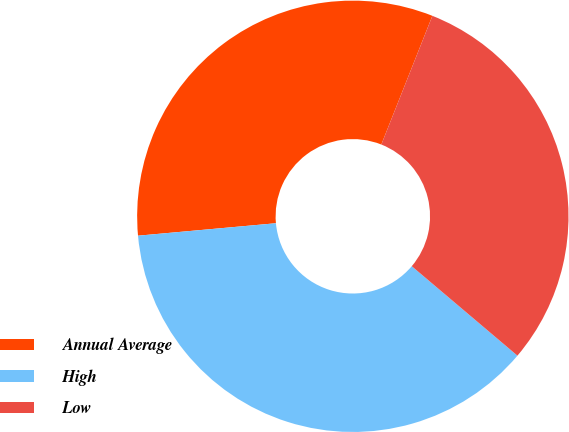<chart> <loc_0><loc_0><loc_500><loc_500><pie_chart><fcel>Annual Average<fcel>High<fcel>Low<nl><fcel>32.45%<fcel>37.39%<fcel>30.17%<nl></chart> 